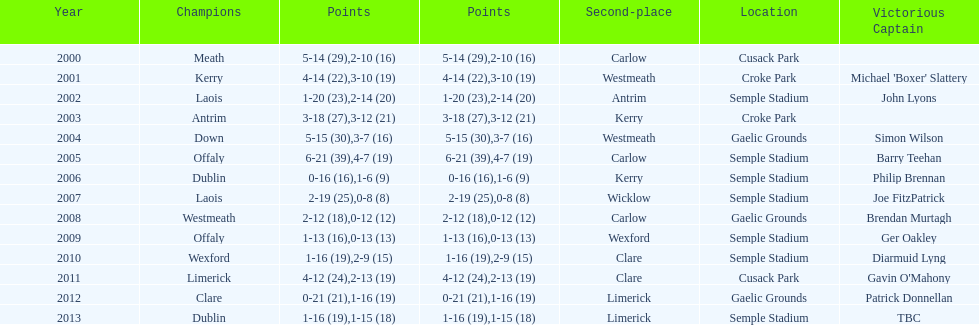Give me the full table as a dictionary. {'header': ['Year', 'Champions', 'Points', 'Points', 'Second-place', 'Location', 'Victorious Captain'], 'rows': [['2000', 'Meath', '5-14 (29)', '2-10 (16)', 'Carlow', 'Cusack Park', ''], ['2001', 'Kerry', '4-14 (22)', '3-10 (19)', 'Westmeath', 'Croke Park', "Michael 'Boxer' Slattery"], ['2002', 'Laois', '1-20 (23)', '2-14 (20)', 'Antrim', 'Semple Stadium', 'John Lyons'], ['2003', 'Antrim', '3-18 (27)', '3-12 (21)', 'Kerry', 'Croke Park', ''], ['2004', 'Down', '5-15 (30)', '3-7 (16)', 'Westmeath', 'Gaelic Grounds', 'Simon Wilson'], ['2005', 'Offaly', '6-21 (39)', '4-7 (19)', 'Carlow', 'Semple Stadium', 'Barry Teehan'], ['2006', 'Dublin', '0-16 (16)', '1-6 (9)', 'Kerry', 'Semple Stadium', 'Philip Brennan'], ['2007', 'Laois', '2-19 (25)', '0-8 (8)', 'Wicklow', 'Semple Stadium', 'Joe FitzPatrick'], ['2008', 'Westmeath', '2-12 (18)', '0-12 (12)', 'Carlow', 'Gaelic Grounds', 'Brendan Murtagh'], ['2009', 'Offaly', '1-13 (16)', '0-13 (13)', 'Wexford', 'Semple Stadium', 'Ger Oakley'], ['2010', 'Wexford', '1-16 (19)', '2-9 (15)', 'Clare', 'Semple Stadium', 'Diarmuid Lyng'], ['2011', 'Limerick', '4-12 (24)', '2-13 (19)', 'Clare', 'Cusack Park', "Gavin O'Mahony"], ['2012', 'Clare', '0-21 (21)', '1-16 (19)', 'Limerick', 'Gaelic Grounds', 'Patrick Donnellan'], ['2013', 'Dublin', '1-16 (19)', '1-15 (18)', 'Limerick', 'Semple Stadium', 'TBC']]} How many times was carlow the runner-up? 3. 